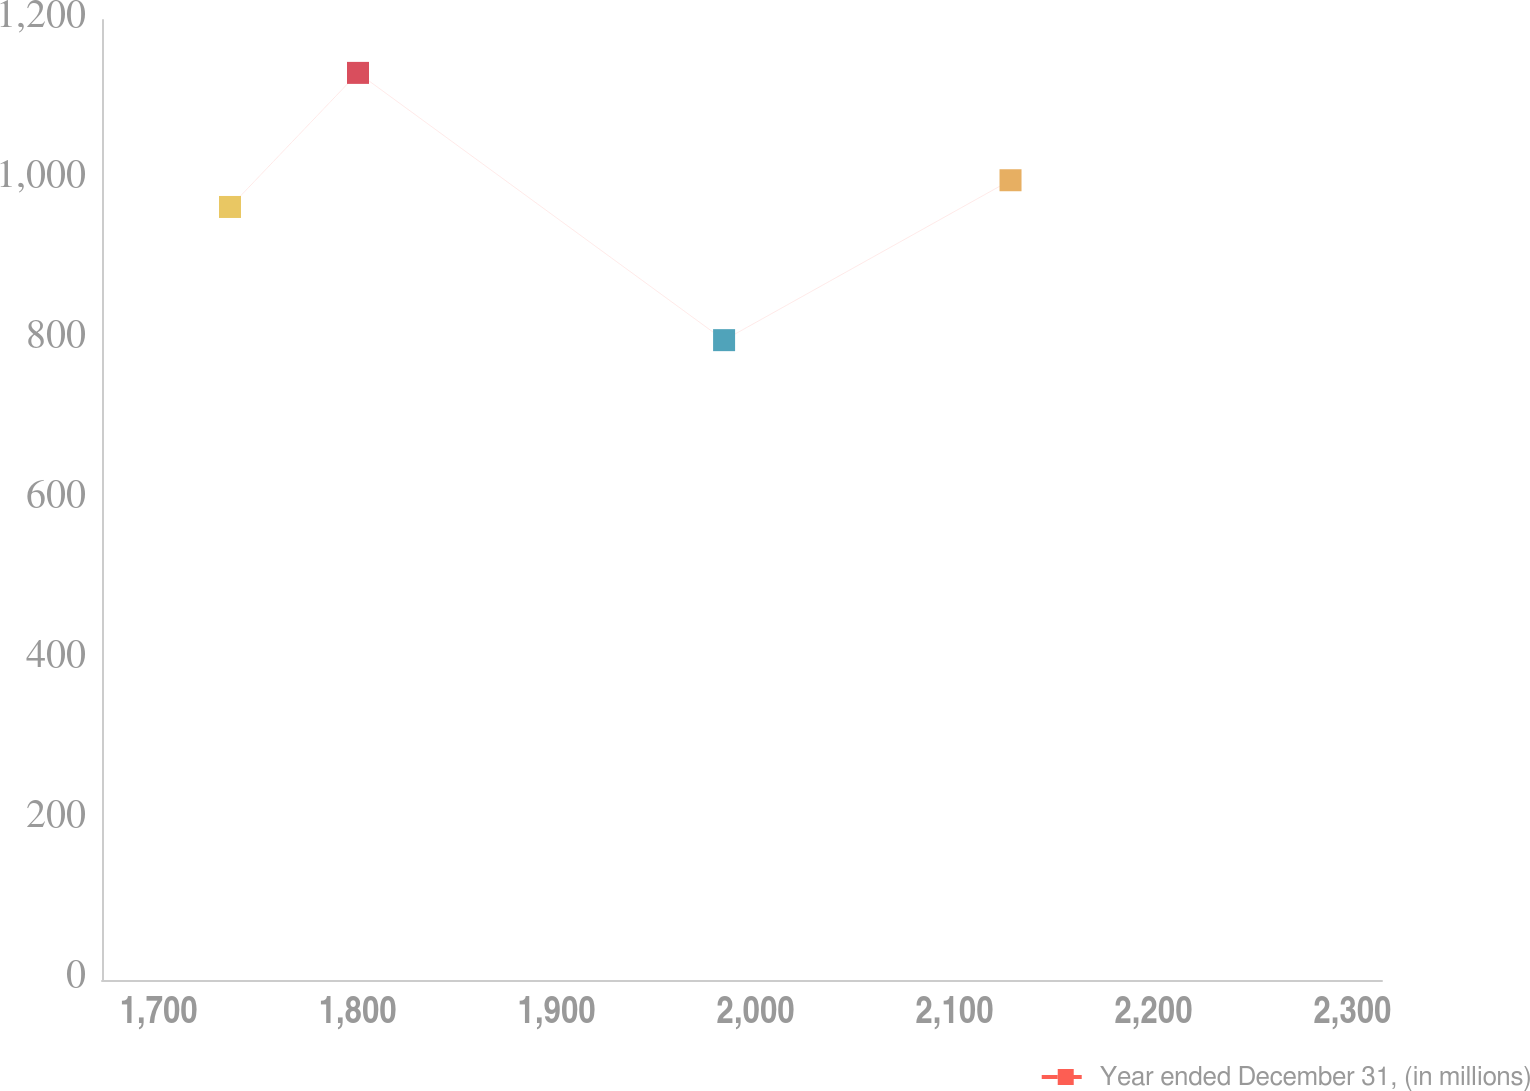Convert chart. <chart><loc_0><loc_0><loc_500><loc_500><line_chart><ecel><fcel>Year ended December 31, (in millions)<nl><fcel>1735.86<fcel>966.29<nl><fcel>1800.19<fcel>1133.89<nl><fcel>1984.19<fcel>799.81<nl><fcel>2128.15<fcel>999.7<nl><fcel>2379.19<fcel>837.62<nl></chart> 